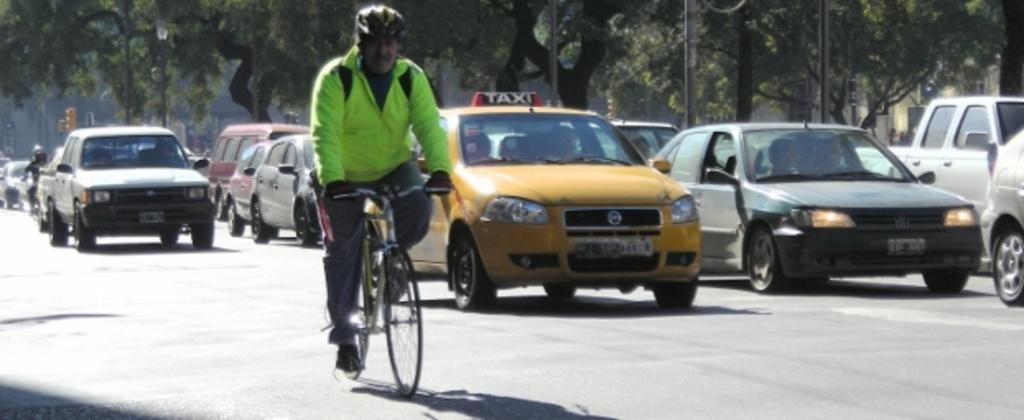<image>
Share a concise interpretation of the image provided. Man riding his bicycle next to a yellow vehicle that says TAXI on top. 